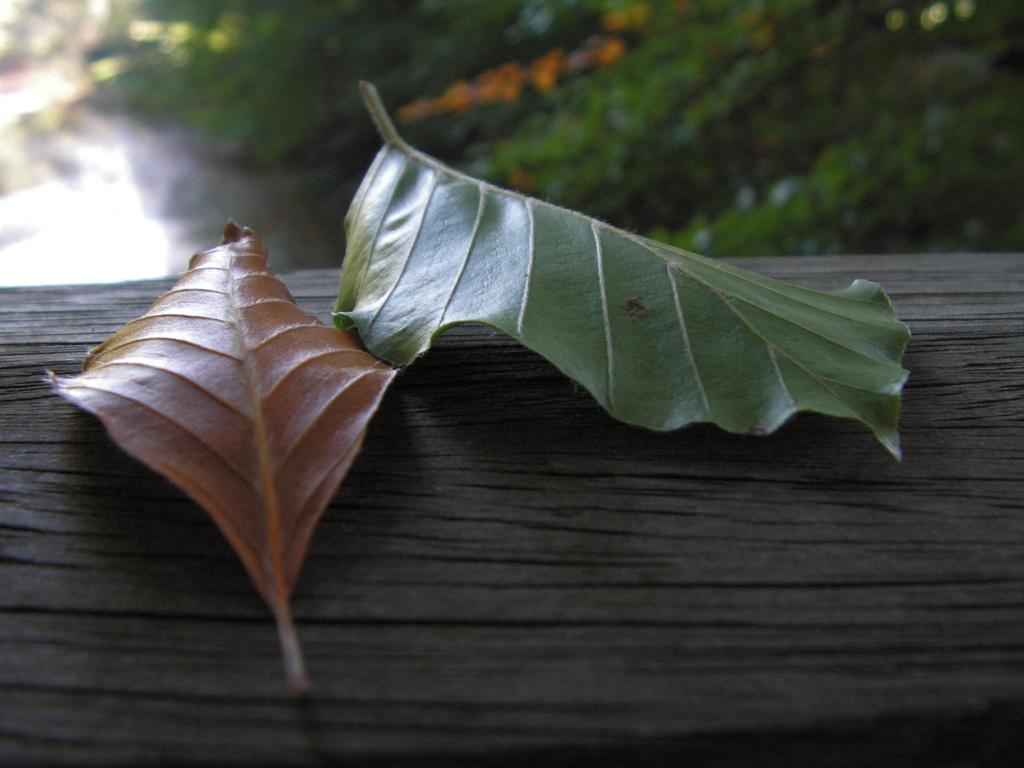What is on the ground in the image? There are leaves on the ground in the image. Can you describe the background of the image? The background of the image is blurred. What type of yarn is being used to create the wind in the image? There is no yarn or wind present in the image; it only features leaves on the ground and a blurred background. 